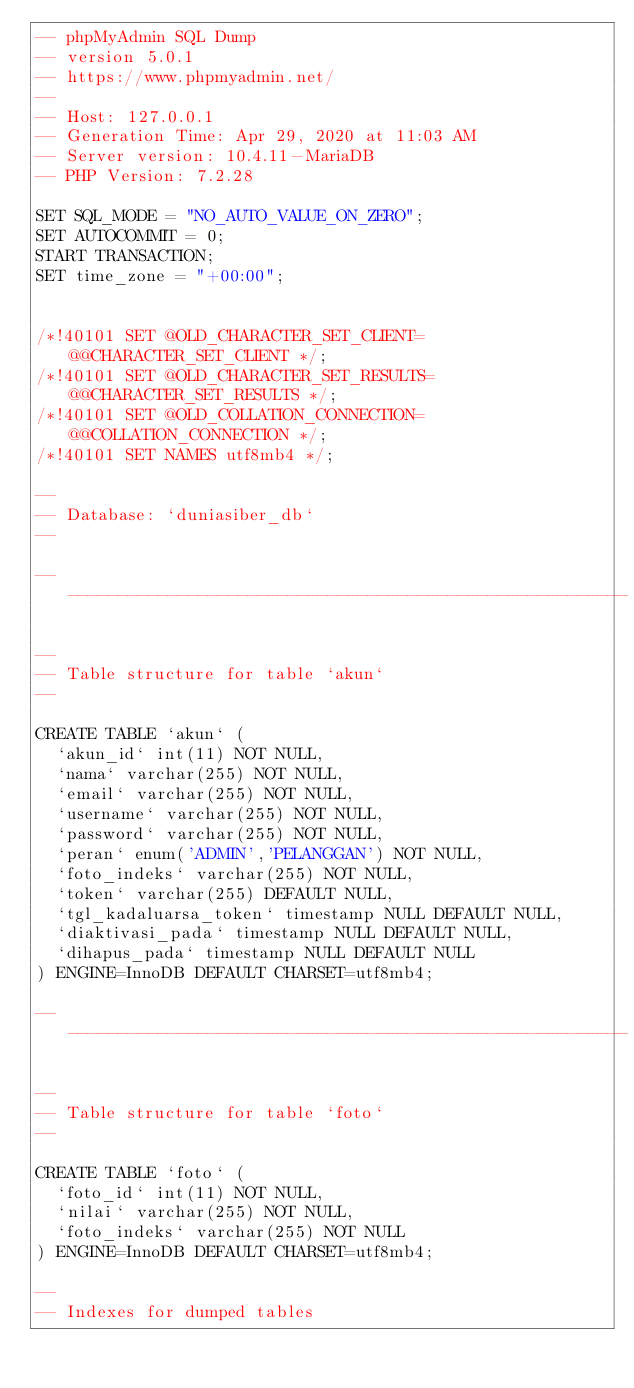Convert code to text. <code><loc_0><loc_0><loc_500><loc_500><_SQL_>-- phpMyAdmin SQL Dump
-- version 5.0.1
-- https://www.phpmyadmin.net/
--
-- Host: 127.0.0.1
-- Generation Time: Apr 29, 2020 at 11:03 AM
-- Server version: 10.4.11-MariaDB
-- PHP Version: 7.2.28

SET SQL_MODE = "NO_AUTO_VALUE_ON_ZERO";
SET AUTOCOMMIT = 0;
START TRANSACTION;
SET time_zone = "+00:00";


/*!40101 SET @OLD_CHARACTER_SET_CLIENT=@@CHARACTER_SET_CLIENT */;
/*!40101 SET @OLD_CHARACTER_SET_RESULTS=@@CHARACTER_SET_RESULTS */;
/*!40101 SET @OLD_COLLATION_CONNECTION=@@COLLATION_CONNECTION */;
/*!40101 SET NAMES utf8mb4 */;

--
-- Database: `duniasiber_db`
--

-- --------------------------------------------------------

--
-- Table structure for table `akun`
--

CREATE TABLE `akun` (
  `akun_id` int(11) NOT NULL,
  `nama` varchar(255) NOT NULL,
  `email` varchar(255) NOT NULL,
  `username` varchar(255) NOT NULL,
  `password` varchar(255) NOT NULL,
  `peran` enum('ADMIN','PELANGGAN') NOT NULL,
  `foto_indeks` varchar(255) NOT NULL,
  `token` varchar(255) DEFAULT NULL,
  `tgl_kadaluarsa_token` timestamp NULL DEFAULT NULL,
  `diaktivasi_pada` timestamp NULL DEFAULT NULL,
  `dihapus_pada` timestamp NULL DEFAULT NULL
) ENGINE=InnoDB DEFAULT CHARSET=utf8mb4;

-- --------------------------------------------------------

--
-- Table structure for table `foto`
--

CREATE TABLE `foto` (
  `foto_id` int(11) NOT NULL,
  `nilai` varchar(255) NOT NULL,
  `foto_indeks` varchar(255) NOT NULL
) ENGINE=InnoDB DEFAULT CHARSET=utf8mb4;

--
-- Indexes for dumped tables</code> 